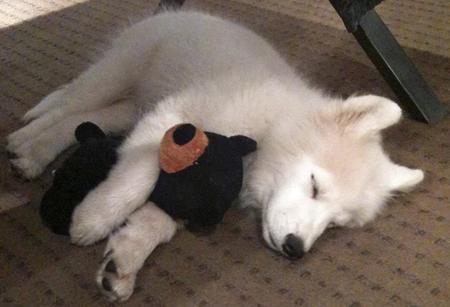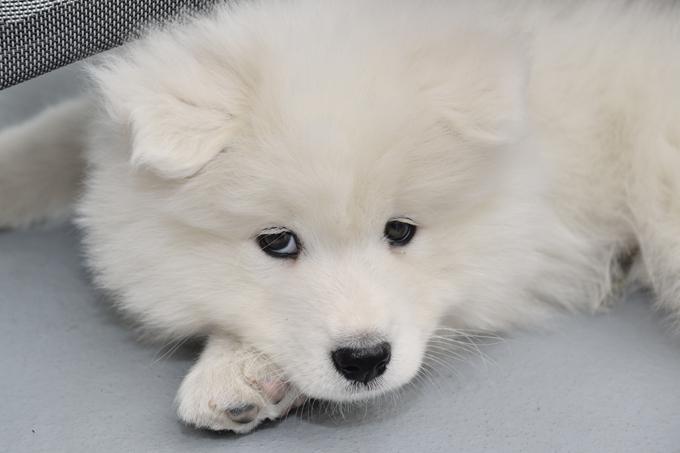The first image is the image on the left, the second image is the image on the right. Evaluate the accuracy of this statement regarding the images: "The single white dog in the image on the right has its eyes open.". Is it true? Answer yes or no. Yes. The first image is the image on the left, the second image is the image on the right. For the images displayed, is the sentence "One image features a reclining white dog with opened eyes." factually correct? Answer yes or no. Yes. 